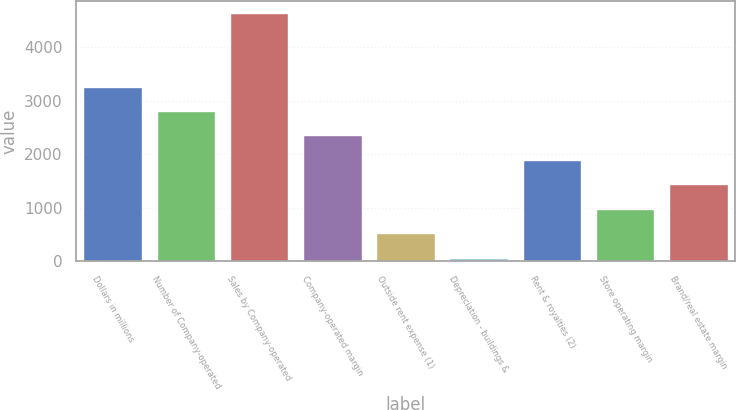Convert chart to OTSL. <chart><loc_0><loc_0><loc_500><loc_500><bar_chart><fcel>Dollars in millions<fcel>Number of Company-operated<fcel>Sales by Company-operated<fcel>Company-operated margin<fcel>Outside rent expense (1)<fcel>Depreciation - buildings &<fcel>Rent & royalties (2)<fcel>Store operating margin<fcel>Brand/real estate margin<nl><fcel>3266.2<fcel>2809.6<fcel>4636<fcel>2353<fcel>526.6<fcel>70<fcel>1896.4<fcel>983.2<fcel>1439.8<nl></chart> 